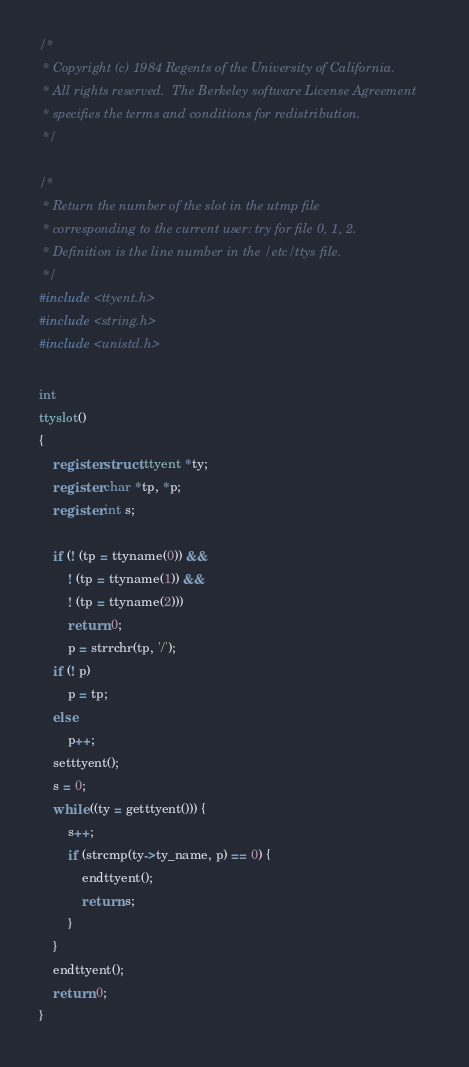<code> <loc_0><loc_0><loc_500><loc_500><_C_>/*
 * Copyright (c) 1984 Regents of the University of California.
 * All rights reserved.  The Berkeley software License Agreement
 * specifies the terms and conditions for redistribution.
 */

/*
 * Return the number of the slot in the utmp file
 * corresponding to the current user: try for file 0, 1, 2.
 * Definition is the line number in the /etc/ttys file.
 */
#include <ttyent.h>
#include <string.h>
#include <unistd.h>

int
ttyslot()
{
	register struct ttyent *ty;
	register char *tp, *p;
	register int s;

	if (! (tp = ttyname(0)) &&
	    ! (tp = ttyname(1)) &&
	    ! (tp = ttyname(2)))
		return 0;
        p = strrchr(tp, '/');
	if (! p)
		p = tp;
	else
		p++;
	setttyent();
	s = 0;
	while ((ty = getttyent())) {
		s++;
		if (strcmp(ty->ty_name, p) == 0) {
			endttyent();
			return s;
		}
	}
	endttyent();
	return 0;
}
</code> 